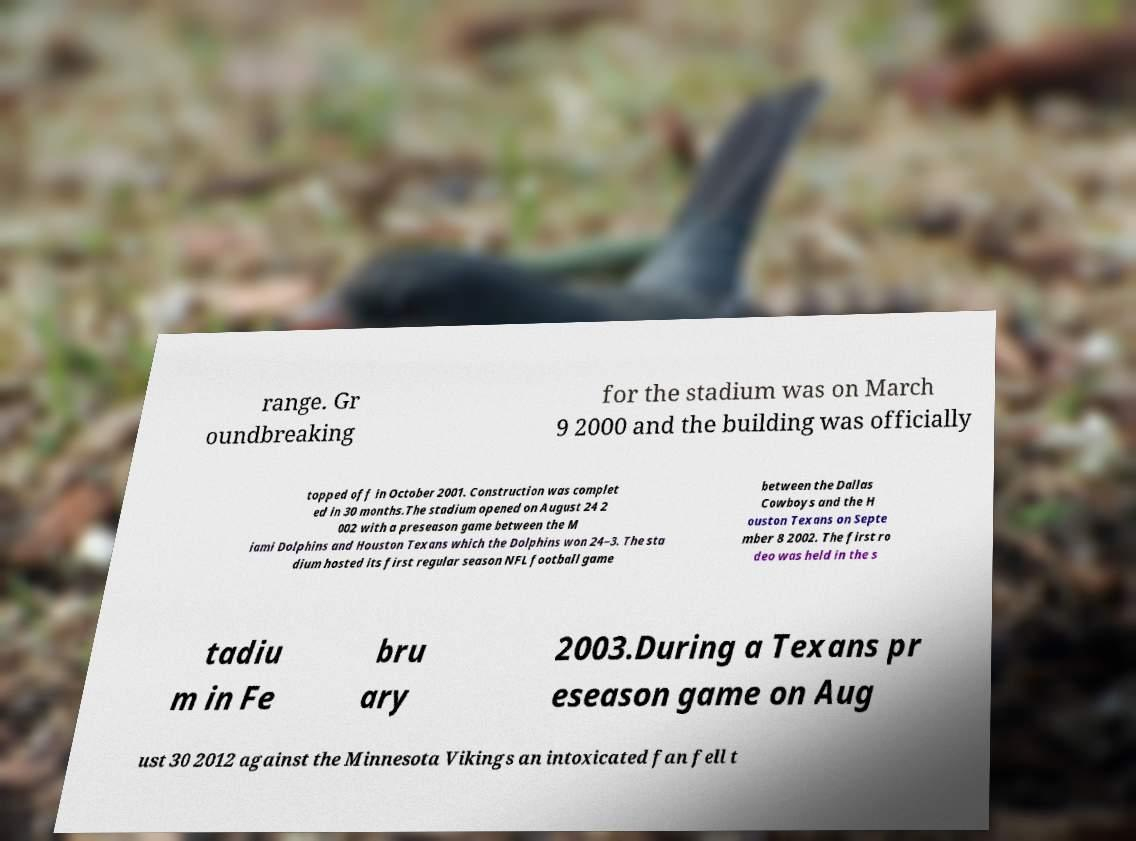Could you extract and type out the text from this image? range. Gr oundbreaking for the stadium was on March 9 2000 and the building was officially topped off in October 2001. Construction was complet ed in 30 months.The stadium opened on August 24 2 002 with a preseason game between the M iami Dolphins and Houston Texans which the Dolphins won 24–3. The sta dium hosted its first regular season NFL football game between the Dallas Cowboys and the H ouston Texans on Septe mber 8 2002. The first ro deo was held in the s tadiu m in Fe bru ary 2003.During a Texans pr eseason game on Aug ust 30 2012 against the Minnesota Vikings an intoxicated fan fell t 